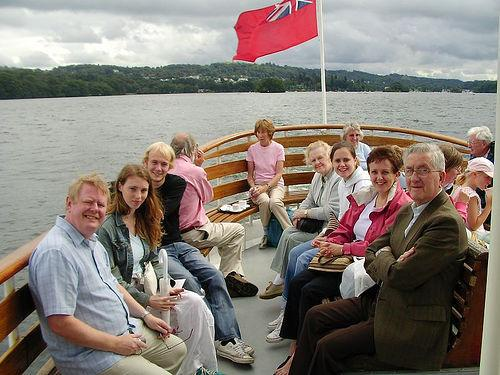What group of people are they likely to be? Please explain your reasoning. europeans. There appears to be a lot of blondes in the boat at a higher percentage than would be found in the general public but at a rate consistent with some eurpoean countries. 